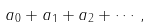Convert formula to latex. <formula><loc_0><loc_0><loc_500><loc_500>a _ { 0 } + a _ { 1 } + a _ { 2 } + \cdots ,</formula> 